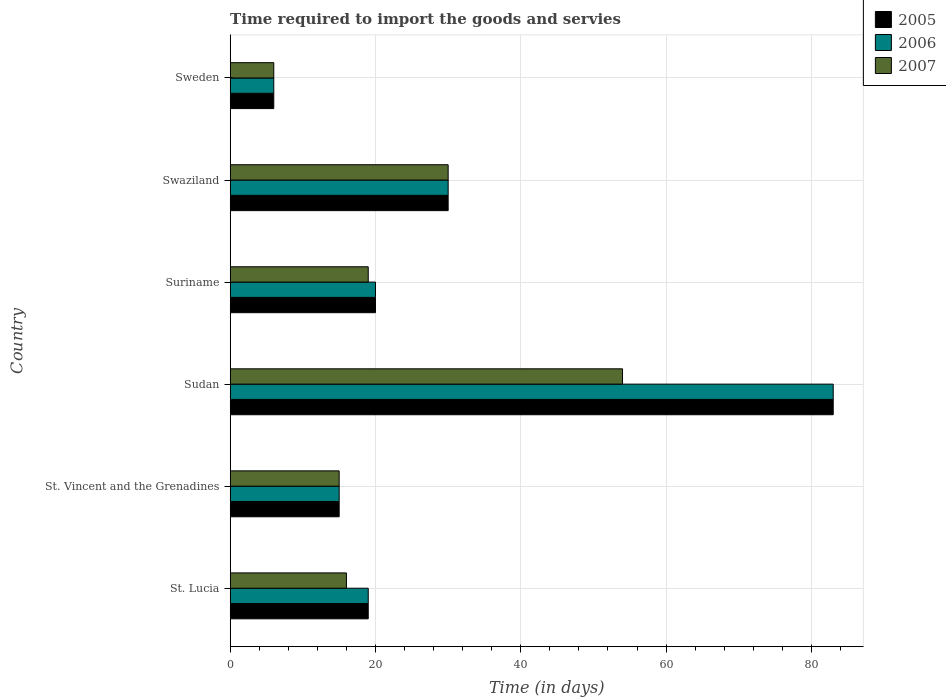How many different coloured bars are there?
Your answer should be compact. 3. How many groups of bars are there?
Offer a terse response. 6. How many bars are there on the 4th tick from the top?
Your answer should be very brief. 3. How many bars are there on the 1st tick from the bottom?
Your answer should be very brief. 3. What is the label of the 5th group of bars from the top?
Your answer should be very brief. St. Vincent and the Grenadines. What is the number of days required to import the goods and services in 2006 in Swaziland?
Your response must be concise. 30. In which country was the number of days required to import the goods and services in 2007 maximum?
Make the answer very short. Sudan. In which country was the number of days required to import the goods and services in 2007 minimum?
Provide a short and direct response. Sweden. What is the total number of days required to import the goods and services in 2005 in the graph?
Your response must be concise. 173. What is the difference between the number of days required to import the goods and services in 2005 in St. Lucia and that in Sudan?
Ensure brevity in your answer.  -64. What is the difference between the number of days required to import the goods and services in 2006 in Suriname and the number of days required to import the goods and services in 2007 in St. Lucia?
Ensure brevity in your answer.  4. What is the average number of days required to import the goods and services in 2006 per country?
Your answer should be very brief. 28.83. In how many countries, is the number of days required to import the goods and services in 2006 greater than 12 days?
Offer a very short reply. 5. What is the ratio of the number of days required to import the goods and services in 2005 in St. Lucia to that in Suriname?
Offer a very short reply. 0.95. In how many countries, is the number of days required to import the goods and services in 2006 greater than the average number of days required to import the goods and services in 2006 taken over all countries?
Give a very brief answer. 2. Is the sum of the number of days required to import the goods and services in 2005 in St. Lucia and Swaziland greater than the maximum number of days required to import the goods and services in 2006 across all countries?
Offer a terse response. No. Is it the case that in every country, the sum of the number of days required to import the goods and services in 2007 and number of days required to import the goods and services in 2006 is greater than the number of days required to import the goods and services in 2005?
Provide a succinct answer. Yes. Are the values on the major ticks of X-axis written in scientific E-notation?
Keep it short and to the point. No. Does the graph contain grids?
Offer a very short reply. Yes. Where does the legend appear in the graph?
Offer a very short reply. Top right. How many legend labels are there?
Keep it short and to the point. 3. What is the title of the graph?
Offer a terse response. Time required to import the goods and servies. What is the label or title of the X-axis?
Offer a very short reply. Time (in days). What is the label or title of the Y-axis?
Offer a terse response. Country. What is the Time (in days) in 2007 in St. Vincent and the Grenadines?
Your response must be concise. 15. What is the Time (in days) in 2007 in Sudan?
Provide a succinct answer. 54. What is the Time (in days) in 2005 in Suriname?
Your response must be concise. 20. What is the Time (in days) in 2006 in Suriname?
Provide a short and direct response. 20. What is the Time (in days) in 2006 in Swaziland?
Offer a terse response. 30. What is the Time (in days) in 2007 in Swaziland?
Give a very brief answer. 30. What is the Time (in days) in 2005 in Sweden?
Offer a very short reply. 6. Across all countries, what is the maximum Time (in days) of 2005?
Your response must be concise. 83. Across all countries, what is the maximum Time (in days) in 2006?
Ensure brevity in your answer.  83. Across all countries, what is the minimum Time (in days) in 2007?
Provide a succinct answer. 6. What is the total Time (in days) in 2005 in the graph?
Provide a succinct answer. 173. What is the total Time (in days) in 2006 in the graph?
Provide a short and direct response. 173. What is the total Time (in days) of 2007 in the graph?
Your answer should be compact. 140. What is the difference between the Time (in days) of 2005 in St. Lucia and that in St. Vincent and the Grenadines?
Ensure brevity in your answer.  4. What is the difference between the Time (in days) in 2005 in St. Lucia and that in Sudan?
Provide a short and direct response. -64. What is the difference between the Time (in days) of 2006 in St. Lucia and that in Sudan?
Ensure brevity in your answer.  -64. What is the difference between the Time (in days) of 2007 in St. Lucia and that in Sudan?
Offer a terse response. -38. What is the difference between the Time (in days) of 2006 in St. Lucia and that in Suriname?
Keep it short and to the point. -1. What is the difference between the Time (in days) of 2005 in St. Lucia and that in Swaziland?
Offer a terse response. -11. What is the difference between the Time (in days) of 2006 in St. Lucia and that in Swaziland?
Offer a very short reply. -11. What is the difference between the Time (in days) of 2007 in St. Lucia and that in Swaziland?
Ensure brevity in your answer.  -14. What is the difference between the Time (in days) of 2007 in St. Lucia and that in Sweden?
Your answer should be very brief. 10. What is the difference between the Time (in days) of 2005 in St. Vincent and the Grenadines and that in Sudan?
Your response must be concise. -68. What is the difference between the Time (in days) in 2006 in St. Vincent and the Grenadines and that in Sudan?
Ensure brevity in your answer.  -68. What is the difference between the Time (in days) in 2007 in St. Vincent and the Grenadines and that in Sudan?
Offer a terse response. -39. What is the difference between the Time (in days) in 2007 in St. Vincent and the Grenadines and that in Suriname?
Your response must be concise. -4. What is the difference between the Time (in days) in 2005 in St. Vincent and the Grenadines and that in Swaziland?
Your response must be concise. -15. What is the difference between the Time (in days) of 2006 in St. Vincent and the Grenadines and that in Swaziland?
Your response must be concise. -15. What is the difference between the Time (in days) of 2007 in St. Vincent and the Grenadines and that in Swaziland?
Make the answer very short. -15. What is the difference between the Time (in days) in 2005 in St. Vincent and the Grenadines and that in Sweden?
Your answer should be very brief. 9. What is the difference between the Time (in days) in 2006 in St. Vincent and the Grenadines and that in Sweden?
Ensure brevity in your answer.  9. What is the difference between the Time (in days) of 2007 in St. Vincent and the Grenadines and that in Sweden?
Offer a terse response. 9. What is the difference between the Time (in days) of 2005 in Sudan and that in Suriname?
Your answer should be very brief. 63. What is the difference between the Time (in days) in 2006 in Sudan and that in Suriname?
Make the answer very short. 63. What is the difference between the Time (in days) of 2007 in Sudan and that in Suriname?
Your answer should be compact. 35. What is the difference between the Time (in days) of 2007 in Sudan and that in Swaziland?
Offer a very short reply. 24. What is the difference between the Time (in days) of 2006 in Sudan and that in Sweden?
Your answer should be compact. 77. What is the difference between the Time (in days) of 2005 in Suriname and that in Swaziland?
Offer a terse response. -10. What is the difference between the Time (in days) of 2007 in Suriname and that in Swaziland?
Your answer should be compact. -11. What is the difference between the Time (in days) in 2005 in Suriname and that in Sweden?
Give a very brief answer. 14. What is the difference between the Time (in days) of 2007 in Suriname and that in Sweden?
Your answer should be very brief. 13. What is the difference between the Time (in days) of 2005 in St. Lucia and the Time (in days) of 2007 in St. Vincent and the Grenadines?
Provide a short and direct response. 4. What is the difference between the Time (in days) in 2006 in St. Lucia and the Time (in days) in 2007 in St. Vincent and the Grenadines?
Keep it short and to the point. 4. What is the difference between the Time (in days) of 2005 in St. Lucia and the Time (in days) of 2006 in Sudan?
Your response must be concise. -64. What is the difference between the Time (in days) of 2005 in St. Lucia and the Time (in days) of 2007 in Sudan?
Give a very brief answer. -35. What is the difference between the Time (in days) in 2006 in St. Lucia and the Time (in days) in 2007 in Sudan?
Offer a very short reply. -35. What is the difference between the Time (in days) of 2005 in St. Lucia and the Time (in days) of 2007 in Suriname?
Ensure brevity in your answer.  0. What is the difference between the Time (in days) in 2005 in St. Vincent and the Grenadines and the Time (in days) in 2006 in Sudan?
Make the answer very short. -68. What is the difference between the Time (in days) of 2005 in St. Vincent and the Grenadines and the Time (in days) of 2007 in Sudan?
Your response must be concise. -39. What is the difference between the Time (in days) in 2006 in St. Vincent and the Grenadines and the Time (in days) in 2007 in Sudan?
Give a very brief answer. -39. What is the difference between the Time (in days) in 2005 in St. Vincent and the Grenadines and the Time (in days) in 2006 in Suriname?
Your answer should be very brief. -5. What is the difference between the Time (in days) of 2006 in St. Vincent and the Grenadines and the Time (in days) of 2007 in Suriname?
Offer a very short reply. -4. What is the difference between the Time (in days) in 2005 in St. Vincent and the Grenadines and the Time (in days) in 2006 in Swaziland?
Provide a short and direct response. -15. What is the difference between the Time (in days) of 2005 in St. Vincent and the Grenadines and the Time (in days) of 2007 in Swaziland?
Your response must be concise. -15. What is the difference between the Time (in days) in 2006 in St. Vincent and the Grenadines and the Time (in days) in 2007 in Swaziland?
Give a very brief answer. -15. What is the difference between the Time (in days) in 2005 in St. Vincent and the Grenadines and the Time (in days) in 2007 in Sweden?
Offer a terse response. 9. What is the difference between the Time (in days) of 2006 in Sudan and the Time (in days) of 2007 in Suriname?
Ensure brevity in your answer.  64. What is the difference between the Time (in days) in 2005 in Sudan and the Time (in days) in 2006 in Swaziland?
Provide a short and direct response. 53. What is the difference between the Time (in days) in 2005 in Sudan and the Time (in days) in 2006 in Sweden?
Give a very brief answer. 77. What is the difference between the Time (in days) of 2005 in Suriname and the Time (in days) of 2006 in Swaziland?
Your response must be concise. -10. What is the difference between the Time (in days) in 2006 in Suriname and the Time (in days) in 2007 in Swaziland?
Ensure brevity in your answer.  -10. What is the difference between the Time (in days) of 2006 in Suriname and the Time (in days) of 2007 in Sweden?
Your answer should be very brief. 14. What is the average Time (in days) in 2005 per country?
Keep it short and to the point. 28.83. What is the average Time (in days) of 2006 per country?
Make the answer very short. 28.83. What is the average Time (in days) of 2007 per country?
Provide a short and direct response. 23.33. What is the difference between the Time (in days) in 2005 and Time (in days) in 2006 in St. Lucia?
Offer a terse response. 0. What is the difference between the Time (in days) in 2005 and Time (in days) in 2007 in St. Lucia?
Ensure brevity in your answer.  3. What is the difference between the Time (in days) in 2006 and Time (in days) in 2007 in St. Lucia?
Ensure brevity in your answer.  3. What is the difference between the Time (in days) in 2005 and Time (in days) in 2006 in St. Vincent and the Grenadines?
Give a very brief answer. 0. What is the difference between the Time (in days) in 2005 and Time (in days) in 2007 in St. Vincent and the Grenadines?
Offer a very short reply. 0. What is the difference between the Time (in days) in 2005 and Time (in days) in 2006 in Sudan?
Your answer should be very brief. 0. What is the difference between the Time (in days) in 2005 and Time (in days) in 2007 in Sudan?
Offer a very short reply. 29. What is the difference between the Time (in days) in 2006 and Time (in days) in 2007 in Sudan?
Your answer should be compact. 29. What is the difference between the Time (in days) of 2005 and Time (in days) of 2007 in Suriname?
Keep it short and to the point. 1. What is the difference between the Time (in days) in 2005 and Time (in days) in 2007 in Swaziland?
Provide a succinct answer. 0. What is the difference between the Time (in days) in 2005 and Time (in days) in 2006 in Sweden?
Your answer should be very brief. 0. What is the difference between the Time (in days) of 2006 and Time (in days) of 2007 in Sweden?
Ensure brevity in your answer.  0. What is the ratio of the Time (in days) of 2005 in St. Lucia to that in St. Vincent and the Grenadines?
Your answer should be compact. 1.27. What is the ratio of the Time (in days) of 2006 in St. Lucia to that in St. Vincent and the Grenadines?
Offer a very short reply. 1.27. What is the ratio of the Time (in days) of 2007 in St. Lucia to that in St. Vincent and the Grenadines?
Ensure brevity in your answer.  1.07. What is the ratio of the Time (in days) in 2005 in St. Lucia to that in Sudan?
Give a very brief answer. 0.23. What is the ratio of the Time (in days) of 2006 in St. Lucia to that in Sudan?
Your answer should be very brief. 0.23. What is the ratio of the Time (in days) in 2007 in St. Lucia to that in Sudan?
Give a very brief answer. 0.3. What is the ratio of the Time (in days) in 2006 in St. Lucia to that in Suriname?
Offer a very short reply. 0.95. What is the ratio of the Time (in days) in 2007 in St. Lucia to that in Suriname?
Your response must be concise. 0.84. What is the ratio of the Time (in days) in 2005 in St. Lucia to that in Swaziland?
Provide a short and direct response. 0.63. What is the ratio of the Time (in days) of 2006 in St. Lucia to that in Swaziland?
Your answer should be compact. 0.63. What is the ratio of the Time (in days) in 2007 in St. Lucia to that in Swaziland?
Give a very brief answer. 0.53. What is the ratio of the Time (in days) of 2005 in St. Lucia to that in Sweden?
Provide a short and direct response. 3.17. What is the ratio of the Time (in days) of 2006 in St. Lucia to that in Sweden?
Your response must be concise. 3.17. What is the ratio of the Time (in days) of 2007 in St. Lucia to that in Sweden?
Offer a very short reply. 2.67. What is the ratio of the Time (in days) in 2005 in St. Vincent and the Grenadines to that in Sudan?
Your answer should be very brief. 0.18. What is the ratio of the Time (in days) in 2006 in St. Vincent and the Grenadines to that in Sudan?
Offer a terse response. 0.18. What is the ratio of the Time (in days) of 2007 in St. Vincent and the Grenadines to that in Sudan?
Offer a terse response. 0.28. What is the ratio of the Time (in days) of 2006 in St. Vincent and the Grenadines to that in Suriname?
Keep it short and to the point. 0.75. What is the ratio of the Time (in days) in 2007 in St. Vincent and the Grenadines to that in Suriname?
Provide a succinct answer. 0.79. What is the ratio of the Time (in days) in 2007 in St. Vincent and the Grenadines to that in Swaziland?
Your answer should be very brief. 0.5. What is the ratio of the Time (in days) in 2005 in St. Vincent and the Grenadines to that in Sweden?
Offer a very short reply. 2.5. What is the ratio of the Time (in days) in 2006 in St. Vincent and the Grenadines to that in Sweden?
Provide a short and direct response. 2.5. What is the ratio of the Time (in days) of 2005 in Sudan to that in Suriname?
Your answer should be very brief. 4.15. What is the ratio of the Time (in days) in 2006 in Sudan to that in Suriname?
Your response must be concise. 4.15. What is the ratio of the Time (in days) in 2007 in Sudan to that in Suriname?
Keep it short and to the point. 2.84. What is the ratio of the Time (in days) of 2005 in Sudan to that in Swaziland?
Make the answer very short. 2.77. What is the ratio of the Time (in days) of 2006 in Sudan to that in Swaziland?
Keep it short and to the point. 2.77. What is the ratio of the Time (in days) in 2005 in Sudan to that in Sweden?
Your answer should be very brief. 13.83. What is the ratio of the Time (in days) in 2006 in Sudan to that in Sweden?
Offer a very short reply. 13.83. What is the ratio of the Time (in days) of 2005 in Suriname to that in Swaziland?
Provide a short and direct response. 0.67. What is the ratio of the Time (in days) in 2007 in Suriname to that in Swaziland?
Give a very brief answer. 0.63. What is the ratio of the Time (in days) of 2007 in Suriname to that in Sweden?
Provide a succinct answer. 3.17. What is the ratio of the Time (in days) in 2005 in Swaziland to that in Sweden?
Ensure brevity in your answer.  5. What is the ratio of the Time (in days) of 2006 in Swaziland to that in Sweden?
Offer a very short reply. 5. What is the ratio of the Time (in days) in 2007 in Swaziland to that in Sweden?
Your answer should be compact. 5. What is the difference between the highest and the second highest Time (in days) in 2005?
Offer a terse response. 53. What is the difference between the highest and the second highest Time (in days) in 2006?
Keep it short and to the point. 53. What is the difference between the highest and the second highest Time (in days) in 2007?
Ensure brevity in your answer.  24. What is the difference between the highest and the lowest Time (in days) in 2005?
Keep it short and to the point. 77. What is the difference between the highest and the lowest Time (in days) in 2006?
Your answer should be very brief. 77. What is the difference between the highest and the lowest Time (in days) of 2007?
Provide a short and direct response. 48. 